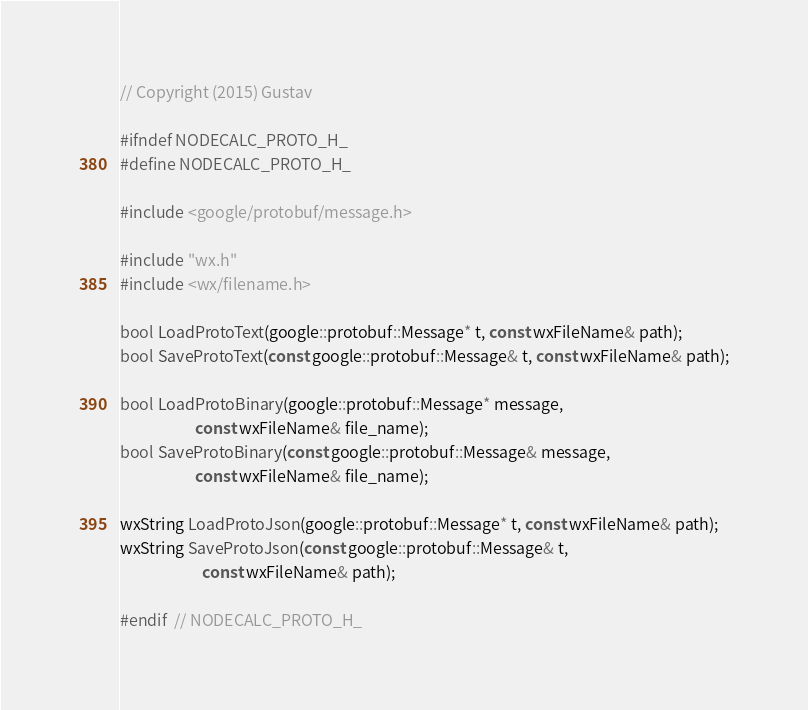<code> <loc_0><loc_0><loc_500><loc_500><_C_>// Copyright (2015) Gustav

#ifndef NODECALC_PROTO_H_
#define NODECALC_PROTO_H_

#include <google/protobuf/message.h>

#include "wx.h"
#include <wx/filename.h>

bool LoadProtoText(google::protobuf::Message* t, const wxFileName& path);
bool SaveProtoText(const google::protobuf::Message& t, const wxFileName& path);

bool LoadProtoBinary(google::protobuf::Message* message,
                     const wxFileName& file_name);
bool SaveProtoBinary(const google::protobuf::Message& message,
                     const wxFileName& file_name);

wxString LoadProtoJson(google::protobuf::Message* t, const wxFileName& path);
wxString SaveProtoJson(const google::protobuf::Message& t,
                       const wxFileName& path);

#endif  // NODECALC_PROTO_H_
</code> 